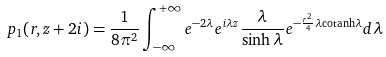<formula> <loc_0><loc_0><loc_500><loc_500>p _ { 1 } ( r , z + 2 i ) = \frac { 1 } { 8 \pi ^ { 2 } } \int _ { - \infty } ^ { + \infty } e ^ { - 2 \lambda } e ^ { i \lambda z } \frac { \lambda } { \sinh \lambda } e ^ { - \frac { r ^ { 2 } } { 4 } \lambda \text {cotanh} \lambda } d \lambda</formula> 